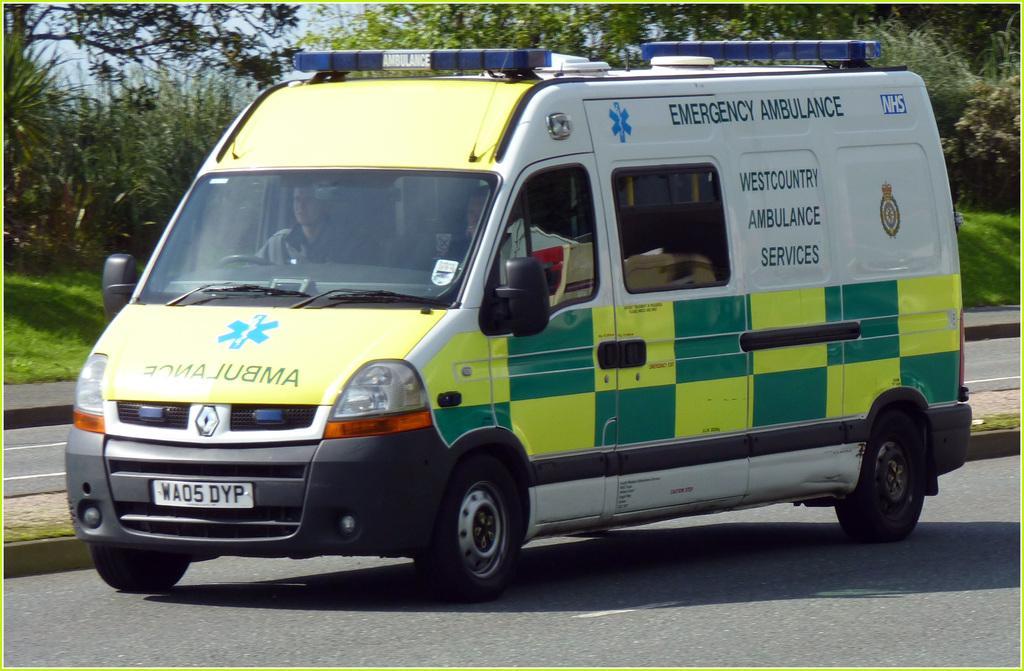Please provide a concise description of this image. In the background we can see the sky, trees and the green grass. In this picture we can see an ambulance on the road. We can see the road divider and persons are visible inside the vehicle. 